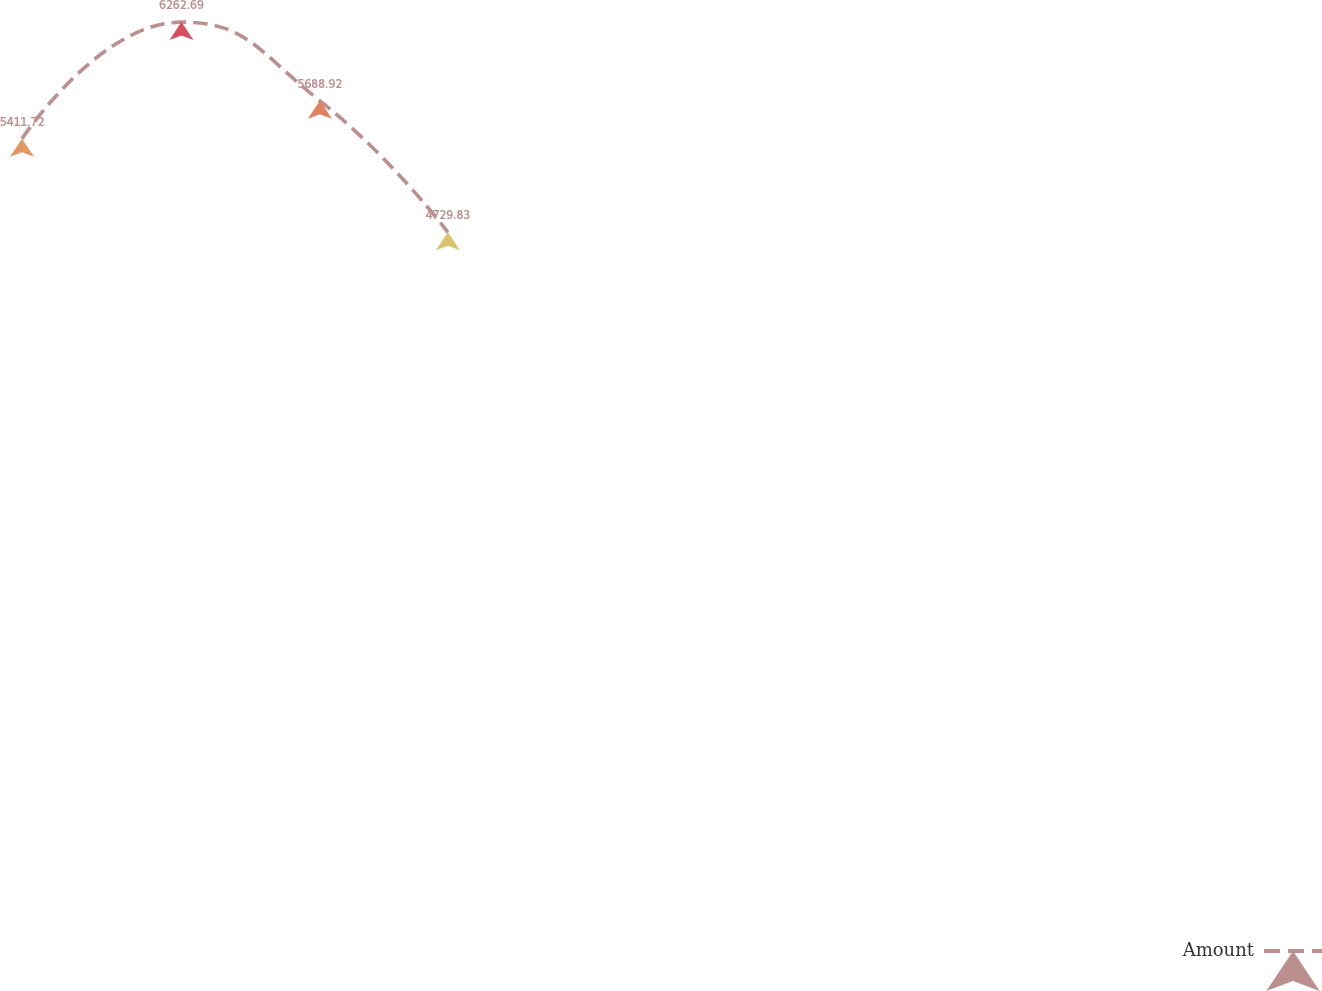Convert chart. <chart><loc_0><loc_0><loc_500><loc_500><line_chart><ecel><fcel>Amount<nl><fcel>1654.39<fcel>5411.72<nl><fcel>1724.83<fcel>6262.69<nl><fcel>1785.97<fcel>5688.92<nl><fcel>1842.51<fcel>4729.83<nl><fcel>2219.8<fcel>3490.71<nl></chart> 